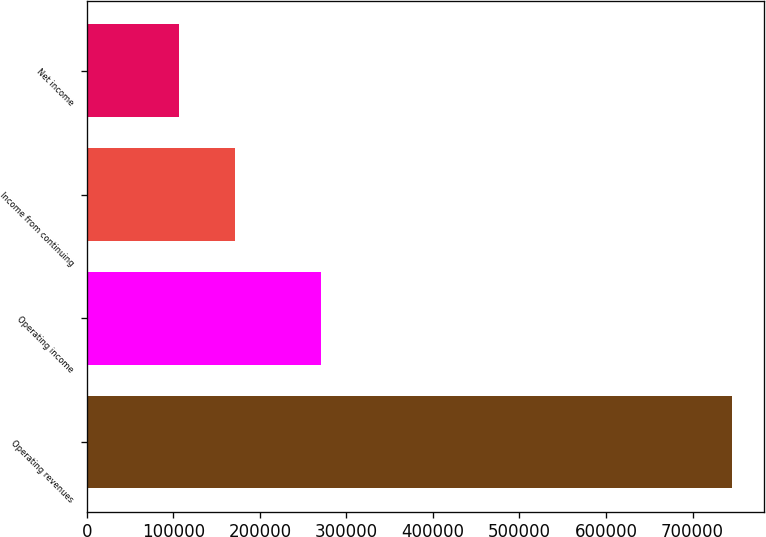<chart> <loc_0><loc_0><loc_500><loc_500><bar_chart><fcel>Operating revenues<fcel>Operating income<fcel>Income from continuing<fcel>Net income<nl><fcel>745607<fcel>270632<fcel>170884<fcel>107026<nl></chart> 